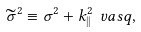Convert formula to latex. <formula><loc_0><loc_0><loc_500><loc_500>\widetilde { \sigma } ^ { 2 } \equiv \sigma ^ { 2 } + k ^ { 2 } _ { | | } \ v a s q ,</formula> 